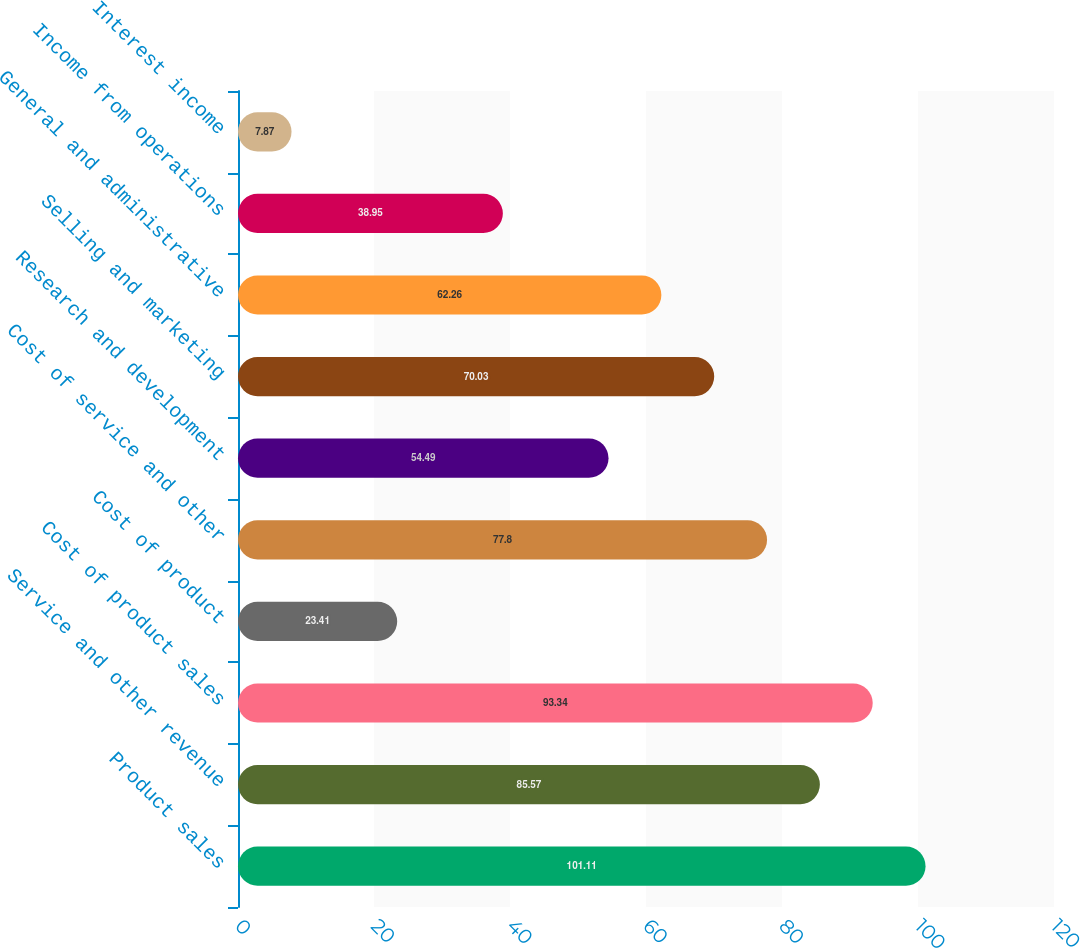<chart> <loc_0><loc_0><loc_500><loc_500><bar_chart><fcel>Product sales<fcel>Service and other revenue<fcel>Cost of product sales<fcel>Cost of product<fcel>Cost of service and other<fcel>Research and development<fcel>Selling and marketing<fcel>General and administrative<fcel>Income from operations<fcel>Interest income<nl><fcel>101.11<fcel>85.57<fcel>93.34<fcel>23.41<fcel>77.8<fcel>54.49<fcel>70.03<fcel>62.26<fcel>38.95<fcel>7.87<nl></chart> 